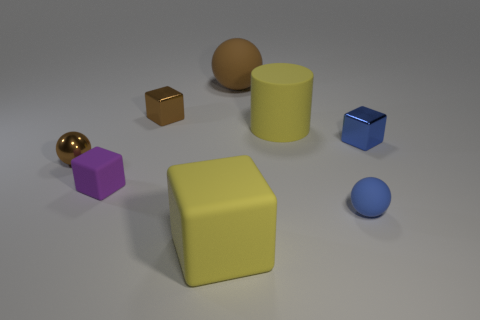Add 1 small blue blocks. How many objects exist? 9 Subtract all balls. How many objects are left? 5 Add 3 blue matte spheres. How many blue matte spheres exist? 4 Subtract 0 gray balls. How many objects are left? 8 Subtract all purple shiny cylinders. Subtract all brown things. How many objects are left? 5 Add 2 small brown metal spheres. How many small brown metal spheres are left? 3 